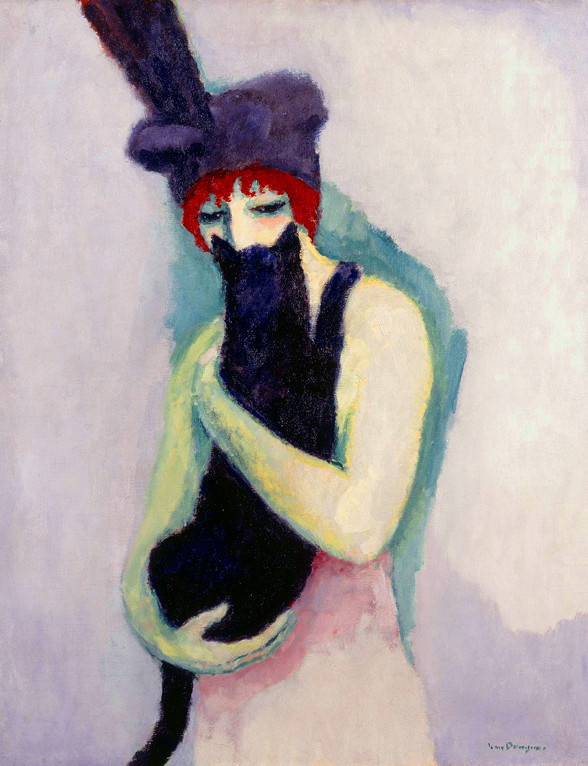What might the choice of her attire signify in this artistic context? The choice of attire, particularly her red hat adorned with a black feather and green shawl, may signal a blend of sophistication with a bohemian spirit, elements often celebrated in post-impressionist art. The boldness of red, typically associated with passion and emotion, complements the tranquil expression of her face, suggesting a complex personality or emotional landscape. The eclectic style can imply a rebellion against conventional norms, a theme prevalent in many post-impressionist works that sought to break away from the strict rules of earlier art movements. How does this align with the historical context of post-impressionist art? Post-impressionist art emerged as a reaction against the naturalistic depictions of Impressionism, concentrating instead on more symbolic, emotional expressions. Artists of this era sought to convey deeper psychological truths, often through exaggerated colors and forms. In this context, the woman's attire and the stylistic elements of the art suggest a deliberate distortion of reality to evoke specific emotional responses from the viewer. This aligns with the movement's inclination towards exploring subjective realities and emotional depth rather than objective accuracy. 